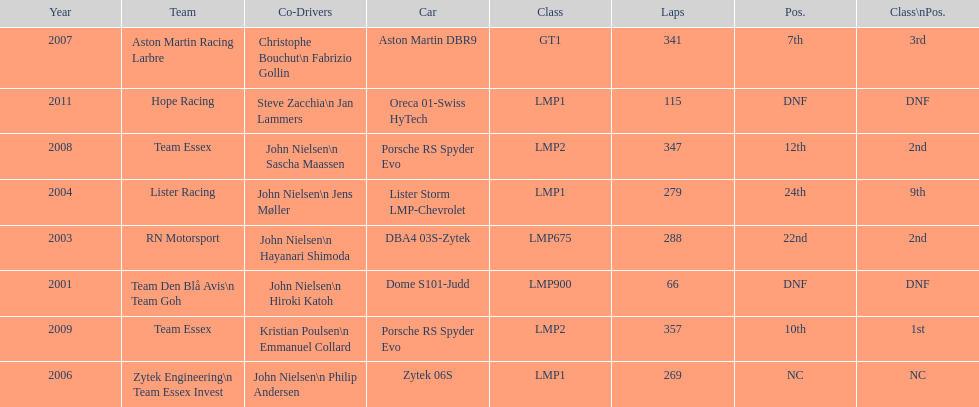In 2008 and what other year was casper elgaard on team essex for the 24 hours of le mans? 2009. 